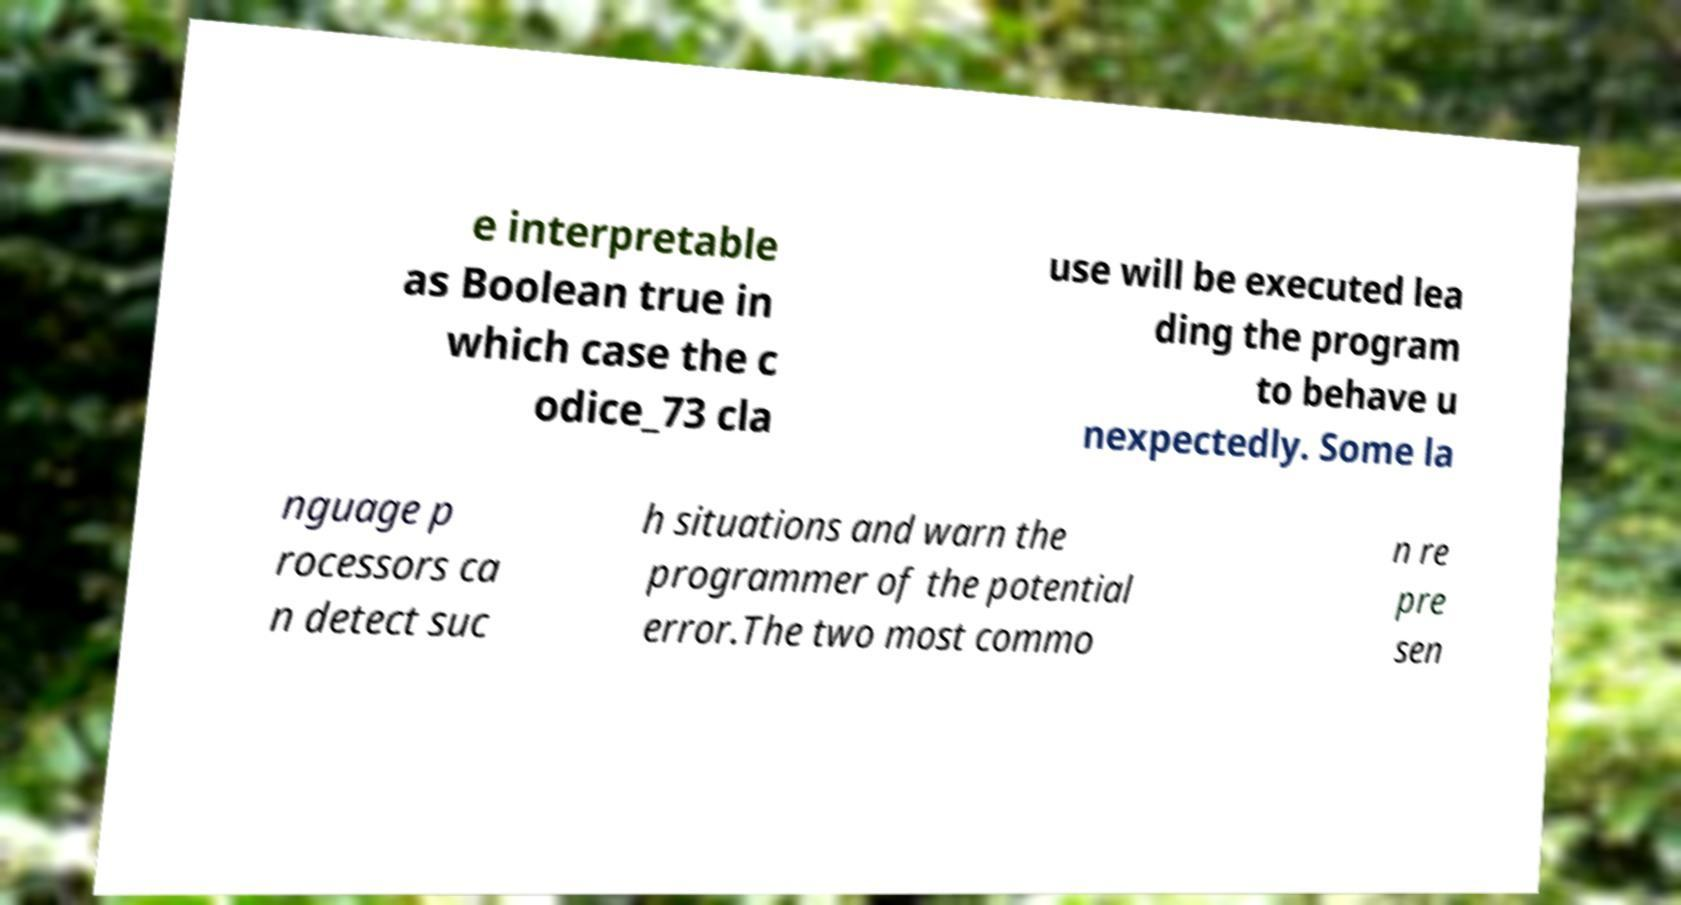Can you read and provide the text displayed in the image?This photo seems to have some interesting text. Can you extract and type it out for me? e interpretable as Boolean true in which case the c odice_73 cla use will be executed lea ding the program to behave u nexpectedly. Some la nguage p rocessors ca n detect suc h situations and warn the programmer of the potential error.The two most commo n re pre sen 